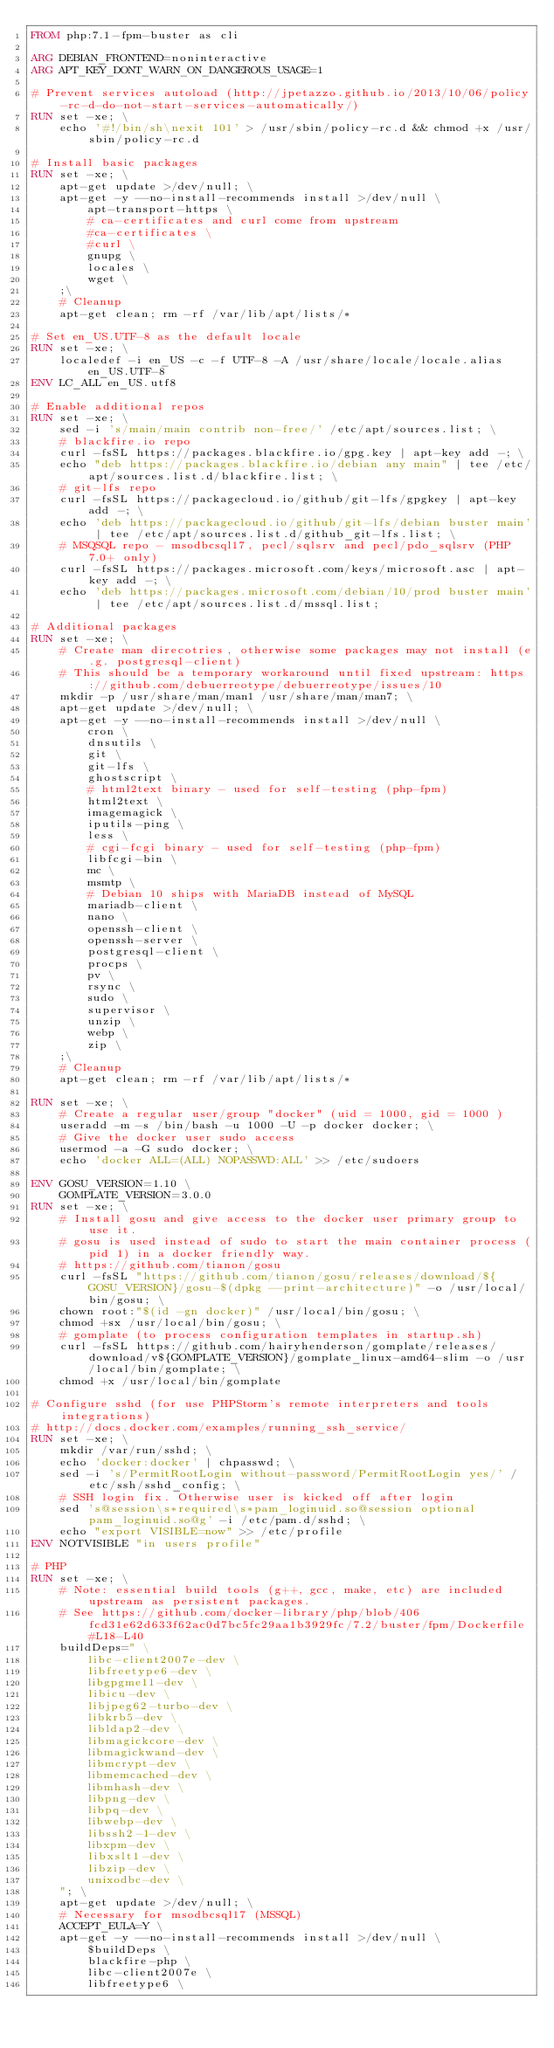Convert code to text. <code><loc_0><loc_0><loc_500><loc_500><_Dockerfile_>FROM php:7.1-fpm-buster as cli

ARG DEBIAN_FRONTEND=noninteractive
ARG APT_KEY_DONT_WARN_ON_DANGEROUS_USAGE=1

# Prevent services autoload (http://jpetazzo.github.io/2013/10/06/policy-rc-d-do-not-start-services-automatically/)
RUN set -xe; \
	echo '#!/bin/sh\nexit 101' > /usr/sbin/policy-rc.d && chmod +x /usr/sbin/policy-rc.d

# Install basic packages
RUN set -xe; \
	apt-get update >/dev/null; \
	apt-get -y --no-install-recommends install >/dev/null \
		apt-transport-https \
		# ca-certificates and curl come from upstream
		#ca-certificates \
		#curl \
		gnupg \
		locales \
		wget \
	;\
	# Cleanup
	apt-get clean; rm -rf /var/lib/apt/lists/*

# Set en_US.UTF-8 as the default locale
RUN set -xe; \
	localedef -i en_US -c -f UTF-8 -A /usr/share/locale/locale.alias en_US.UTF-8
ENV LC_ALL en_US.utf8

# Enable additional repos
RUN set -xe; \
	sed -i 's/main/main contrib non-free/' /etc/apt/sources.list; \
	# blackfire.io repo
	curl -fsSL https://packages.blackfire.io/gpg.key | apt-key add -; \
	echo "deb https://packages.blackfire.io/debian any main" | tee /etc/apt/sources.list.d/blackfire.list; \
	# git-lfs repo
	curl -fsSL https://packagecloud.io/github/git-lfs/gpgkey | apt-key add -; \
	echo 'deb https://packagecloud.io/github/git-lfs/debian buster main' | tee /etc/apt/sources.list.d/github_git-lfs.list; \
	# MSQSQL repo - msodbcsql17, pecl/sqlsrv and pecl/pdo_sqlsrv (PHP 7.0+ only)
	curl -fsSL https://packages.microsoft.com/keys/microsoft.asc | apt-key add -; \
	echo 'deb https://packages.microsoft.com/debian/10/prod buster main' | tee /etc/apt/sources.list.d/mssql.list;

# Additional packages
RUN set -xe; \
	# Create man direcotries, otherwise some packages may not install (e.g. postgresql-client)
	# This should be a temporary workaround until fixed upstream: https://github.com/debuerreotype/debuerreotype/issues/10
	mkdir -p /usr/share/man/man1 /usr/share/man/man7; \
	apt-get update >/dev/null; \
	apt-get -y --no-install-recommends install >/dev/null \
		cron \
		dnsutils \
		git \
		git-lfs \
		ghostscript \
		# html2text binary - used for self-testing (php-fpm)
		html2text \
		imagemagick \
		iputils-ping \
		less \
		# cgi-fcgi binary - used for self-testing (php-fpm)
		libfcgi-bin \
		mc \
		msmtp \
		# Debian 10 ships with MariaDB instead of MySQL
		mariadb-client \
		nano \
		openssh-client \
		openssh-server \
		postgresql-client \
		procps \
		pv \
		rsync \
		sudo \
		supervisor \
		unzip \
		webp \
		zip \
	;\
	# Cleanup
	apt-get clean; rm -rf /var/lib/apt/lists/*

RUN set -xe; \
	# Create a regular user/group "docker" (uid = 1000, gid = 1000 )
	useradd -m -s /bin/bash -u 1000 -U -p docker docker; \
	# Give the docker user sudo access
	usermod -a -G sudo docker; \
	echo 'docker ALL=(ALL) NOPASSWD:ALL' >> /etc/sudoers

ENV GOSU_VERSION=1.10 \
	GOMPLATE_VERSION=3.0.0
RUN set -xe; \
	# Install gosu and give access to the docker user primary group to use it.
	# gosu is used instead of sudo to start the main container process (pid 1) in a docker friendly way.
	# https://github.com/tianon/gosu
	curl -fsSL "https://github.com/tianon/gosu/releases/download/${GOSU_VERSION}/gosu-$(dpkg --print-architecture)" -o /usr/local/bin/gosu; \
	chown root:"$(id -gn docker)" /usr/local/bin/gosu; \
	chmod +sx /usr/local/bin/gosu; \
	# gomplate (to process configuration templates in startup.sh)
	curl -fsSL https://github.com/hairyhenderson/gomplate/releases/download/v${GOMPLATE_VERSION}/gomplate_linux-amd64-slim -o /usr/local/bin/gomplate; \
	chmod +x /usr/local/bin/gomplate

# Configure sshd (for use PHPStorm's remote interpreters and tools integrations)
# http://docs.docker.com/examples/running_ssh_service/
RUN set -xe; \
	mkdir /var/run/sshd; \
	echo 'docker:docker' | chpasswd; \
	sed -i 's/PermitRootLogin without-password/PermitRootLogin yes/' /etc/ssh/sshd_config; \
	# SSH login fix. Otherwise user is kicked off after login
	sed 's@session\s*required\s*pam_loginuid.so@session optional pam_loginuid.so@g' -i /etc/pam.d/sshd; \
	echo "export VISIBLE=now" >> /etc/profile
ENV NOTVISIBLE "in users profile"

# PHP
RUN set -xe; \
	# Note: essential build tools (g++, gcc, make, etc) are included upstream as persistent packages.
	# See https://github.com/docker-library/php/blob/406fcd31e62d633f62ac0d7bc5fc29aa1b3929fc/7.2/buster/fpm/Dockerfile#L18-L40
	buildDeps=" \
		libc-client2007e-dev \
		libfreetype6-dev \
		libgpgme11-dev \
		libicu-dev \
		libjpeg62-turbo-dev \
		libkrb5-dev \
		libldap2-dev \
		libmagickcore-dev \
		libmagickwand-dev \
		libmcrypt-dev \
		libmemcached-dev \
		libmhash-dev \
		libpng-dev \
		libpq-dev \
		libwebp-dev \
		libssh2-1-dev \
		libxpm-dev \
		libxslt1-dev \
		libzip-dev \
		unixodbc-dev \
	"; \
	apt-get update >/dev/null; \
	# Necessary for msodbcsql17 (MSSQL)
	ACCEPT_EULA=Y \
	apt-get -y --no-install-recommends install >/dev/null \
		$buildDeps \
		blackfire-php \
		libc-client2007e \
		libfreetype6 \</code> 